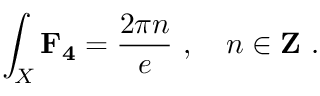Convert formula to latex. <formula><loc_0><loc_0><loc_500><loc_500>\int _ { X } F _ { 4 } = \frac { 2 \pi n } { e } \ , \quad n \in { Z } \ .</formula> 